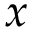Convert formula to latex. <formula><loc_0><loc_0><loc_500><loc_500>x</formula> 